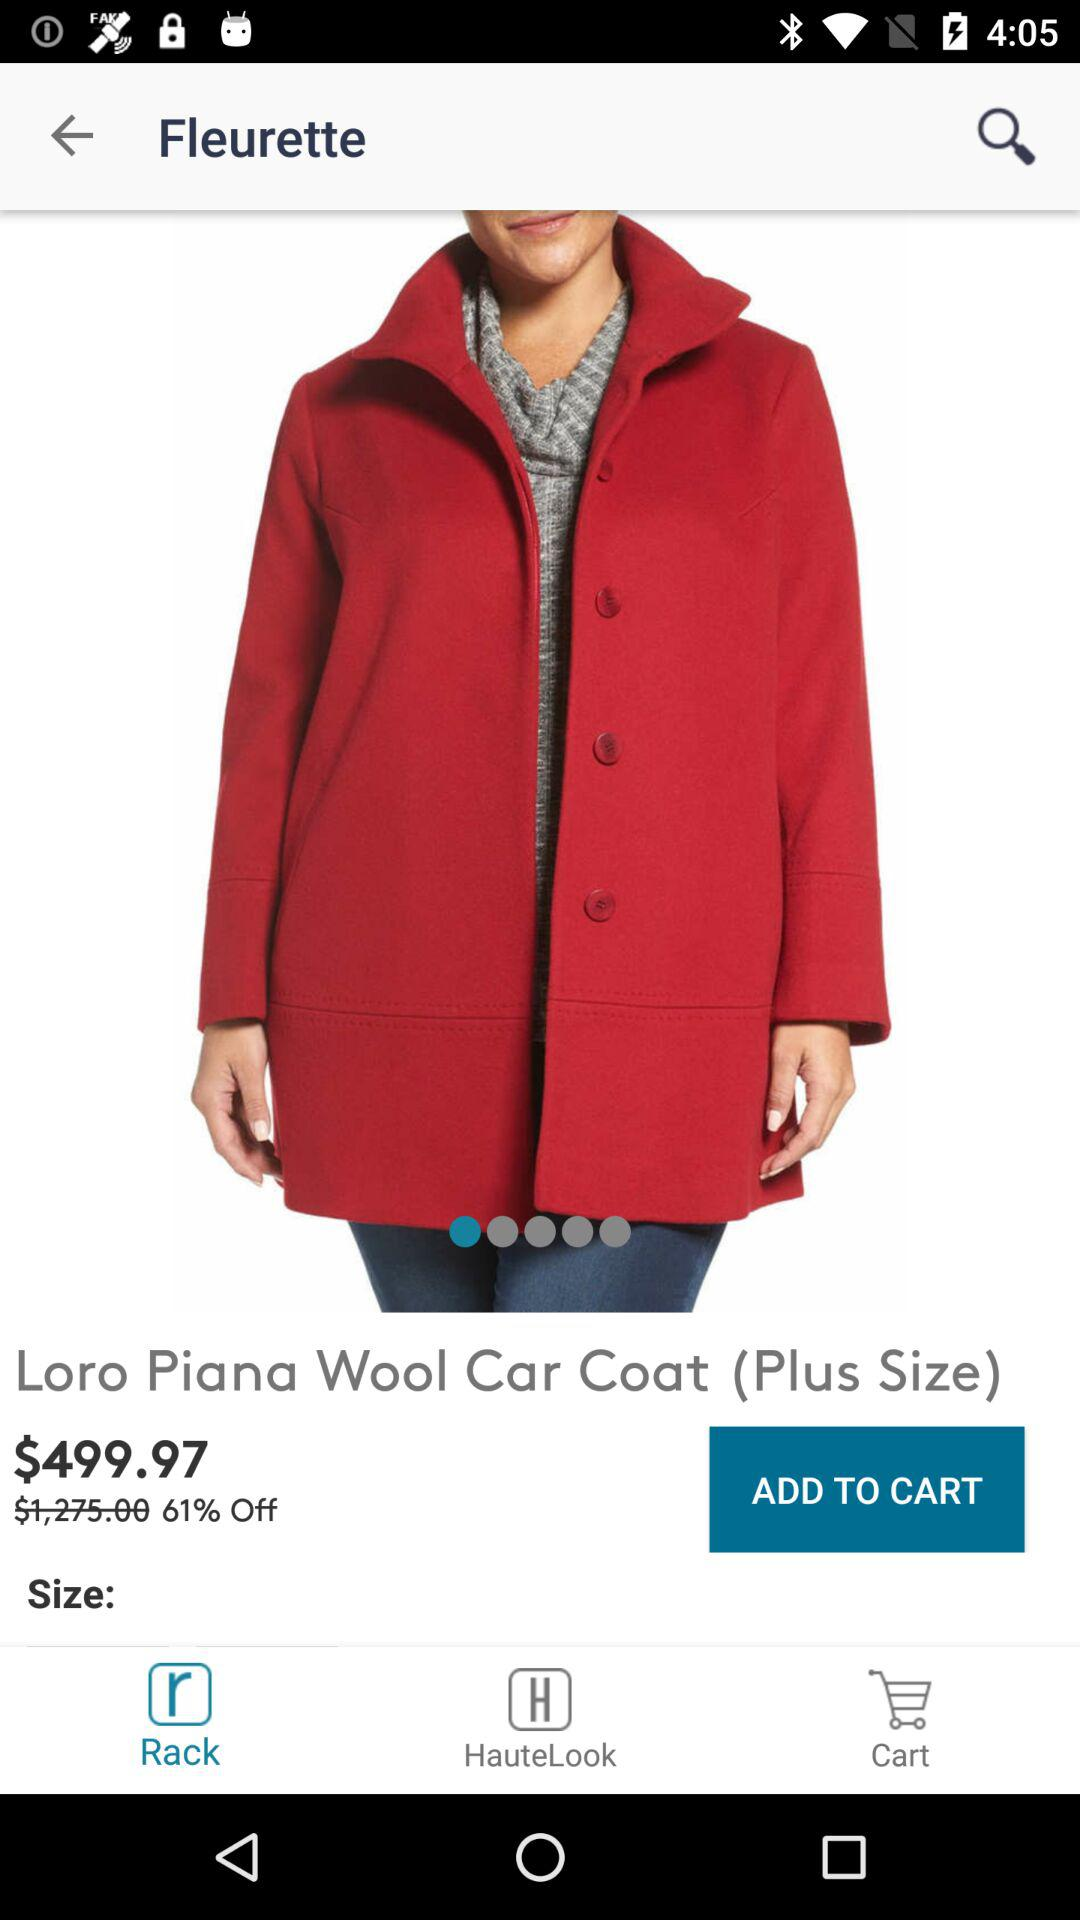Which colors are available for the wool coat?
When the provided information is insufficient, respond with <no answer>. <no answer> 